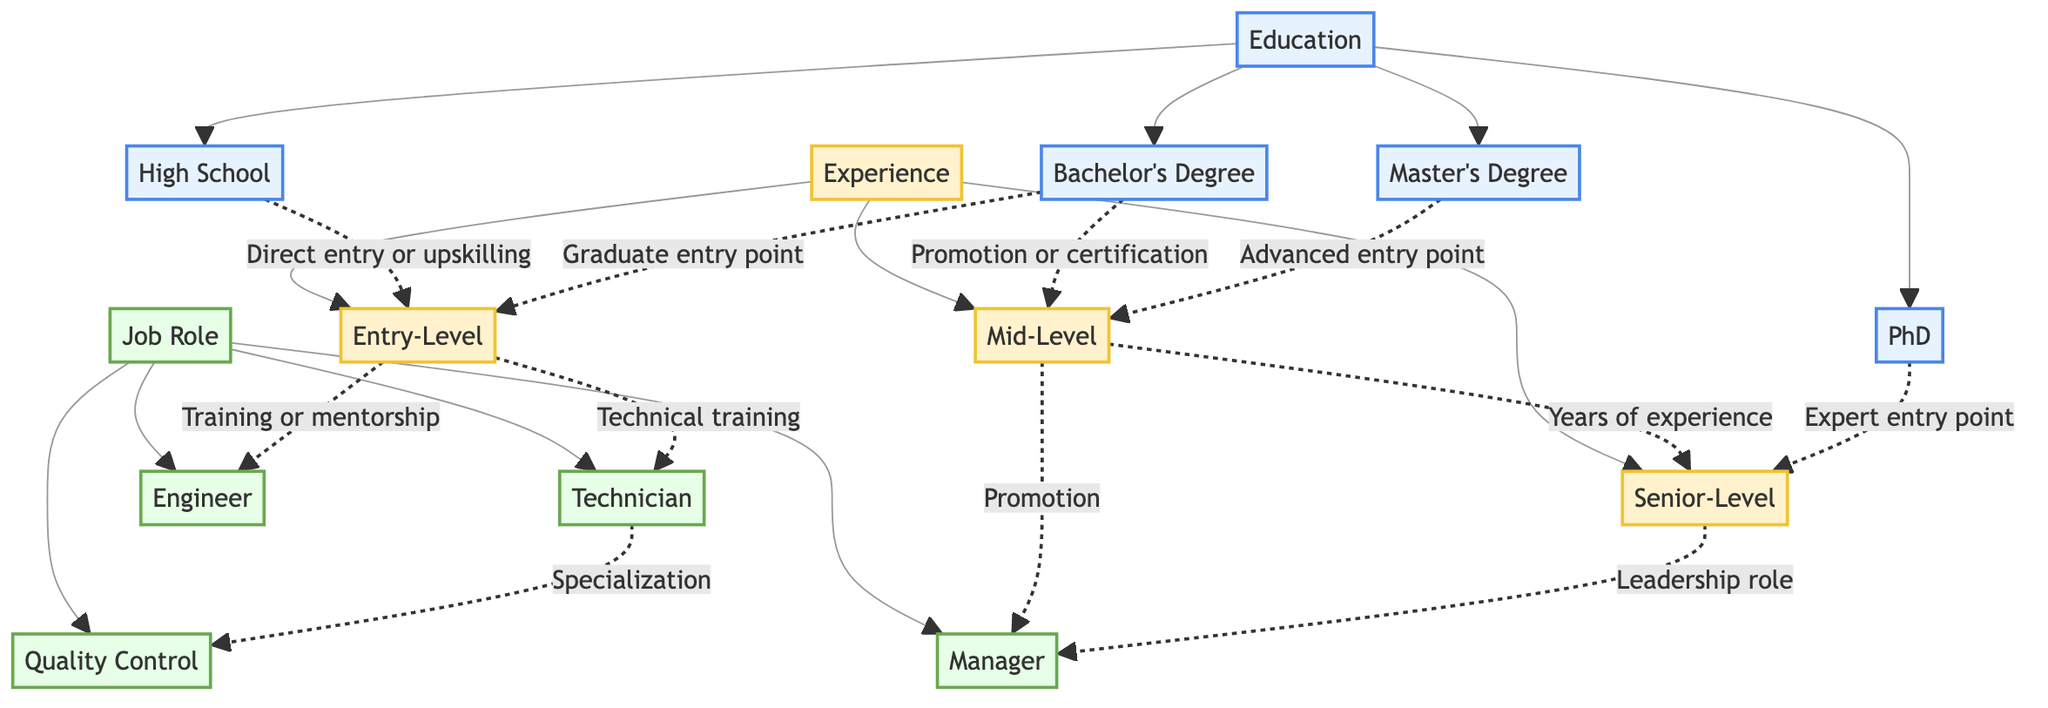What educational backgrounds can lead to entry-level roles? The diagram shows two educational paths leading to entry-level roles: high school and bachelor's degree. Both are represented as direct connections to the entry-level node.
Answer: High School, Bachelor's Degree How many types of job roles are depicted in the diagram? By counting the job roles listed, there are four types of jobs shown: engineer, technician, quality control, and manager.
Answer: 4 Which educational qualification corresponds to the highest level of experience? The PhD node leads to the senior-level experience. Among all educational qualifications listed, the PhD is associated with higher senior-level positions.
Answer: PhD What is the relationship between mid-level experience and management roles? The mid-level experience connects to the management role through a promotion relationship, indicating that advancement to a managerial position typically comes from mid-level positions.
Answer: Promotion From which experience level do technicians receive their training? The entry-level experience node connects to technician roles through a training relationship, thereby indicating that technicians start from entry-level.
Answer: Entry-Level What role is associated with specialization in quality control? Technicians are shown to have a connection with quality control through a specialization relationship, implying that quality control roles emerge from technician experiences.
Answer: Technician Which education level leads directly to senior-level experience without intermediate steps? The PhD connects to senior-level experience directly, indicating that it is an expert entry point that does not require previous experience levels.
Answer: PhD How does an entry-level experience lead to the engineer role? The entry-level experience directly points to the engineer role through a training or mentorship path, meaning individuals in entry-level can become engineers after receiving adequate training.
Answer: Training or mentorship 